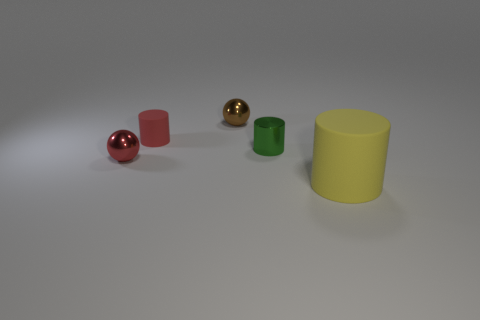There is a small sphere that is in front of the small red matte object; is it the same color as the tiny matte cylinder?
Give a very brief answer. Yes. What shape is the other thing that is the same color as the small matte object?
Your answer should be compact. Sphere. There is another thing that is the same color as the small rubber object; what is its size?
Make the answer very short. Small. There is a thing that is both behind the small green metallic cylinder and on the left side of the tiny brown shiny ball; what size is it?
Ensure brevity in your answer.  Small. Does the green thing have the same shape as the tiny metallic object in front of the small green shiny thing?
Provide a succinct answer. No. The other rubber thing that is the same shape as the small rubber thing is what size?
Offer a terse response. Large. Does the tiny rubber thing have the same color as the thing to the left of the red matte object?
Offer a terse response. Yes. How many other objects are there of the same size as the red rubber cylinder?
Provide a succinct answer. 3. What shape is the metal object that is behind the small cylinder that is to the right of the sphere that is to the right of the red matte cylinder?
Give a very brief answer. Sphere. There is a brown sphere; is its size the same as the matte object right of the tiny green cylinder?
Ensure brevity in your answer.  No. 